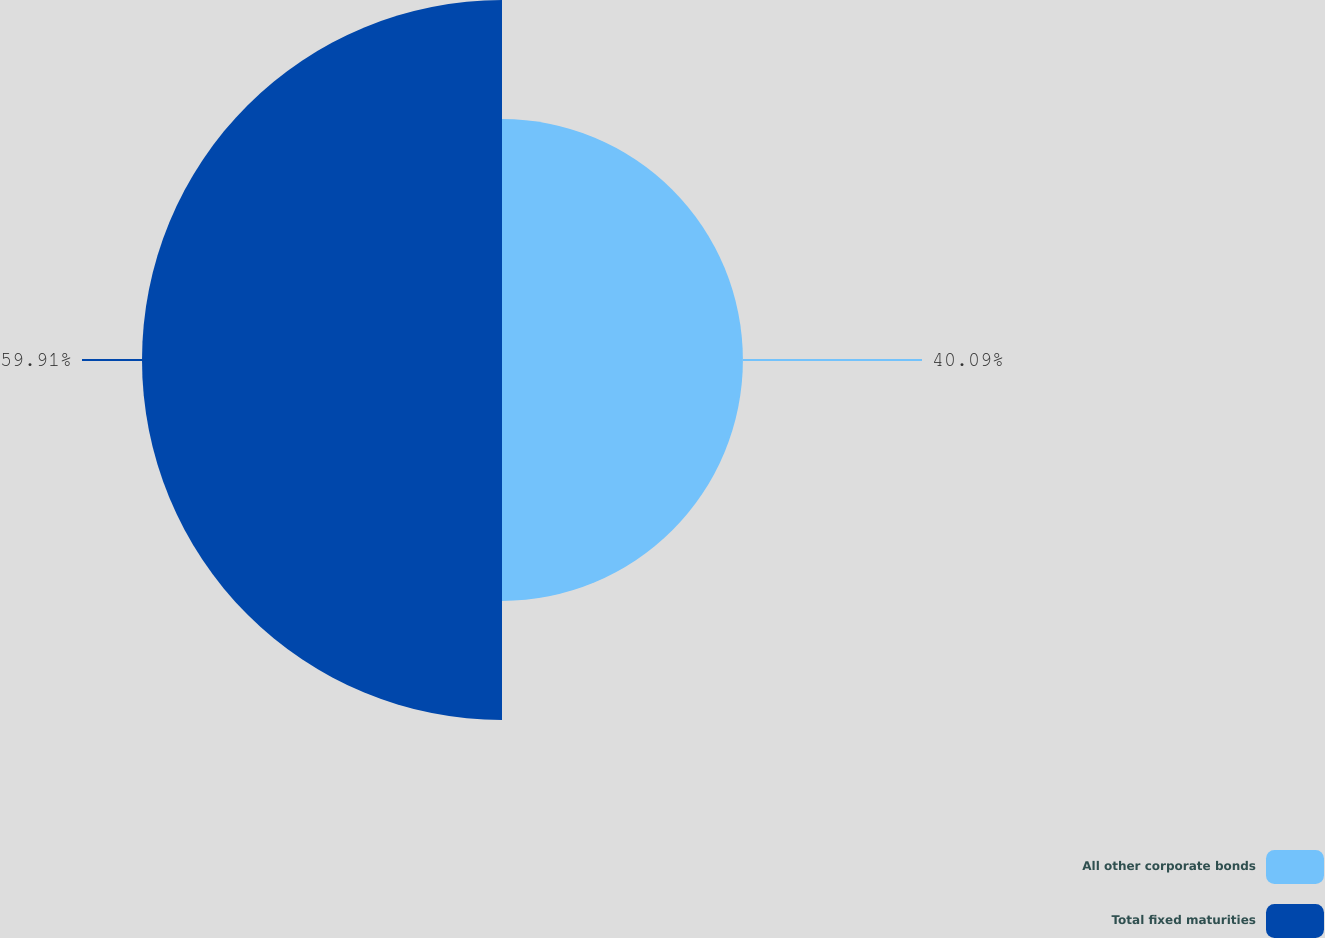Convert chart. <chart><loc_0><loc_0><loc_500><loc_500><pie_chart><fcel>All other corporate bonds<fcel>Total fixed maturities<nl><fcel>40.09%<fcel>59.91%<nl></chart> 